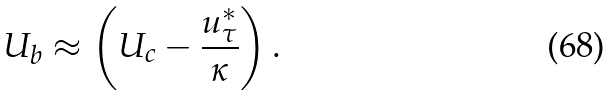<formula> <loc_0><loc_0><loc_500><loc_500>U _ { b } \approx \left ( U _ { c } - \frac { u _ { \tau } ^ { * } } { \kappa } \right ) .</formula> 